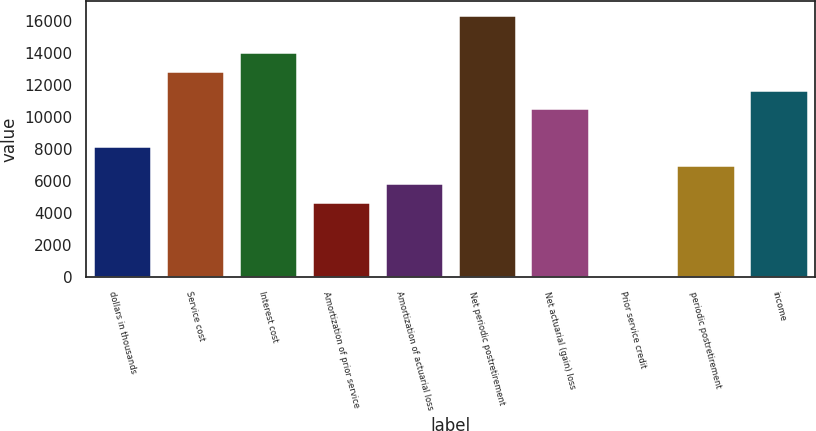<chart> <loc_0><loc_0><loc_500><loc_500><bar_chart><fcel>dollars in thousands<fcel>Service cost<fcel>Interest cost<fcel>Amortization of prior service<fcel>Amortization of actuarial loss<fcel>Net periodic postretirement<fcel>Net actuarial (gain) loss<fcel>Prior service credit<fcel>periodic postretirement<fcel>income<nl><fcel>8201.05<fcel>12885<fcel>14056<fcel>4688.05<fcel>5859.05<fcel>16398<fcel>10543<fcel>4.05<fcel>7030.05<fcel>11714<nl></chart> 